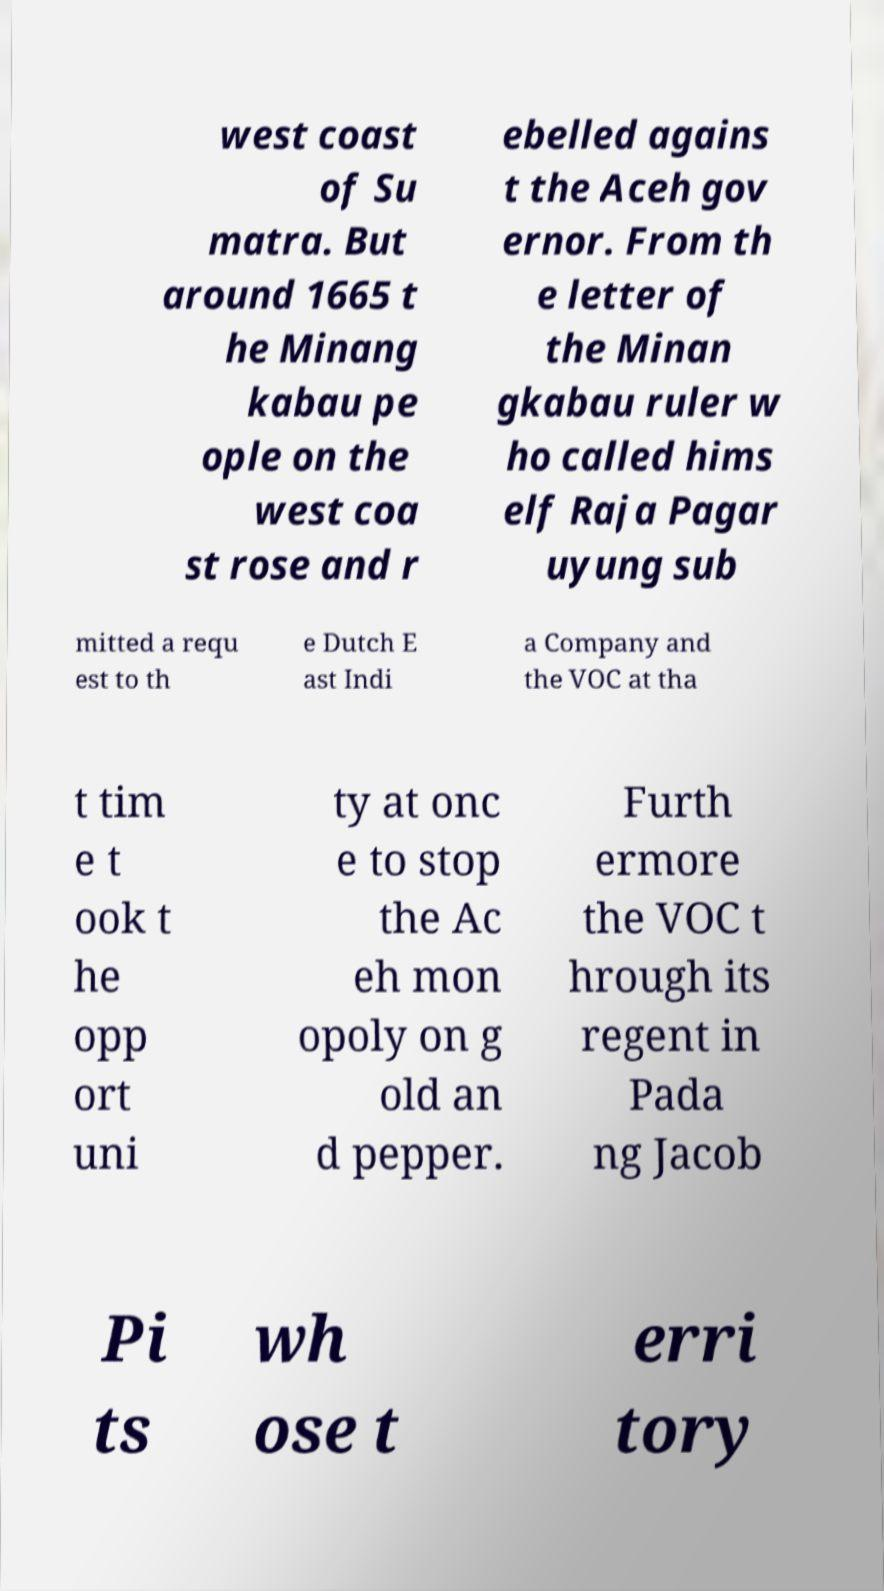What messages or text are displayed in this image? I need them in a readable, typed format. west coast of Su matra. But around 1665 t he Minang kabau pe ople on the west coa st rose and r ebelled agains t the Aceh gov ernor. From th e letter of the Minan gkabau ruler w ho called hims elf Raja Pagar uyung sub mitted a requ est to th e Dutch E ast Indi a Company and the VOC at tha t tim e t ook t he opp ort uni ty at onc e to stop the Ac eh mon opoly on g old an d pepper. Furth ermore the VOC t hrough its regent in Pada ng Jacob Pi ts wh ose t erri tory 